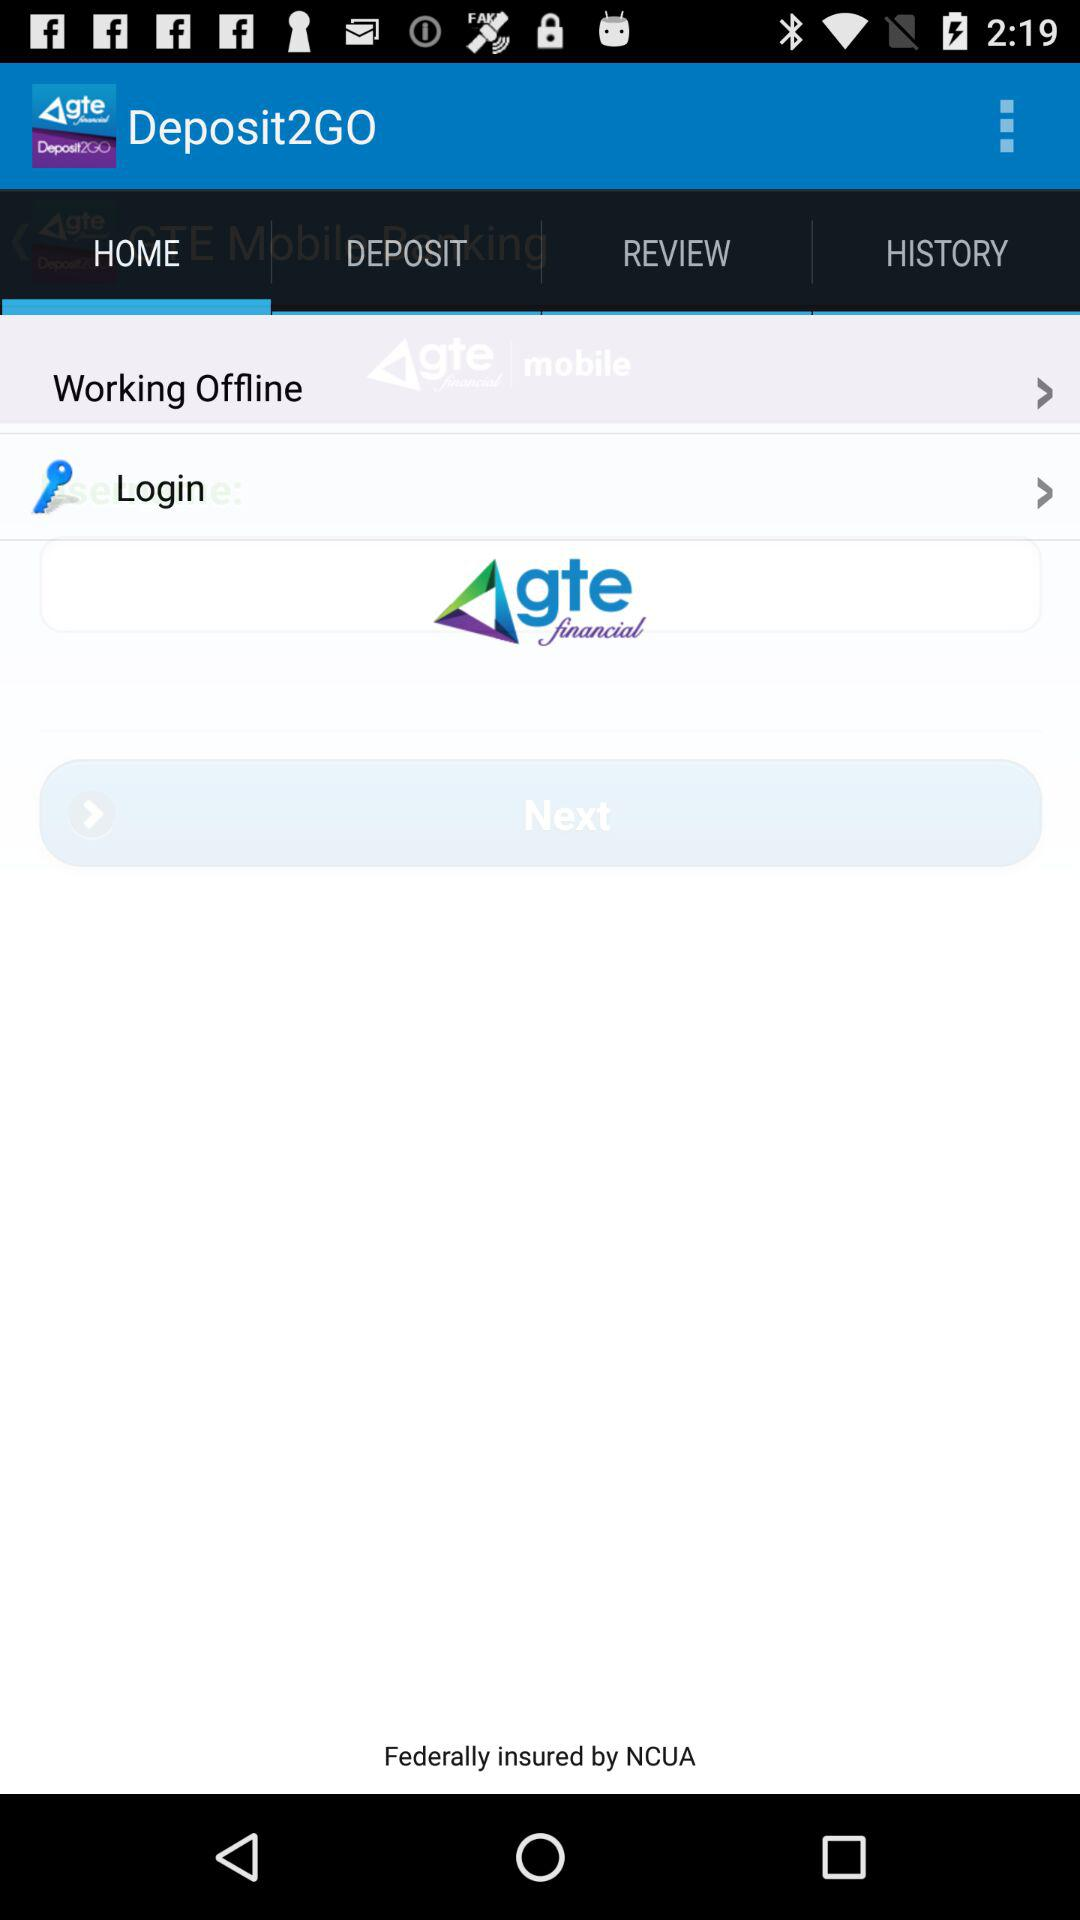How many people are working offline?
When the provided information is insufficient, respond with <no answer>. <no answer> 